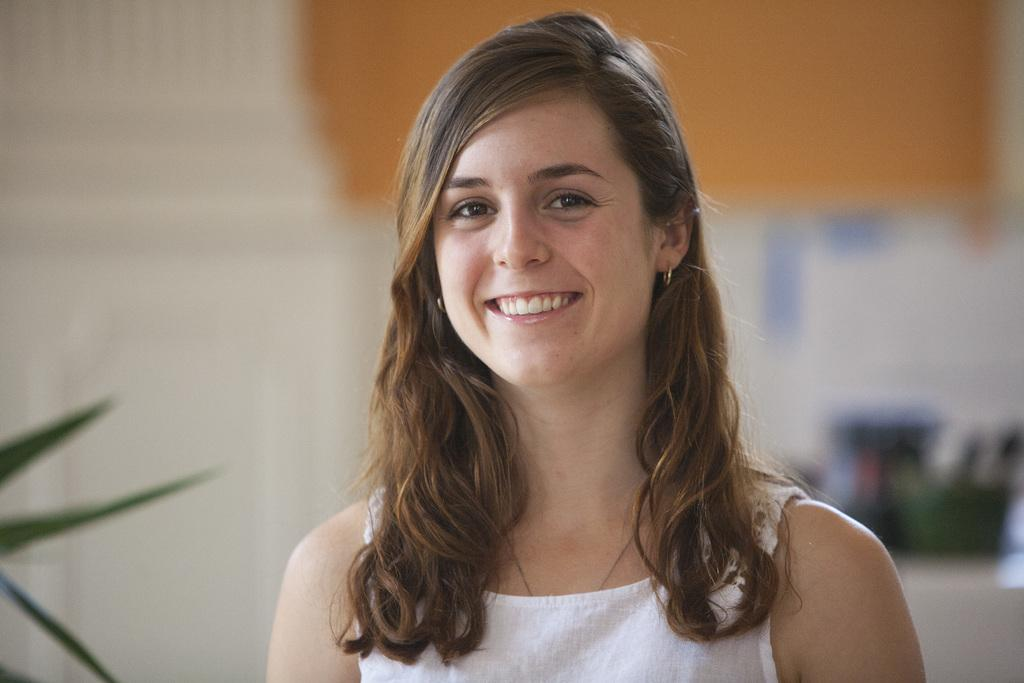Who is present in the image? There is a woman in the image. What is the woman wearing? The woman is wearing a white dress. What is the woman's facial expression? The woman is smiling. What can be seen on the left side of the image? There are leaves visible on the left side of the image. How would you describe the background of the image? The background of the image is blurred. What type of lettuce is being used as a hook in the image? There is no lettuce or hook present in the image. Can you tell me how many basketballs are visible in the image? There are no basketballs visible in the image. 